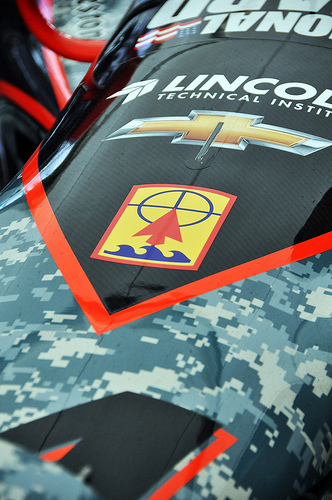<image>
Can you confirm if the orange stripe is behind the black paint? No. The orange stripe is not behind the black paint. From this viewpoint, the orange stripe appears to be positioned elsewhere in the scene. 